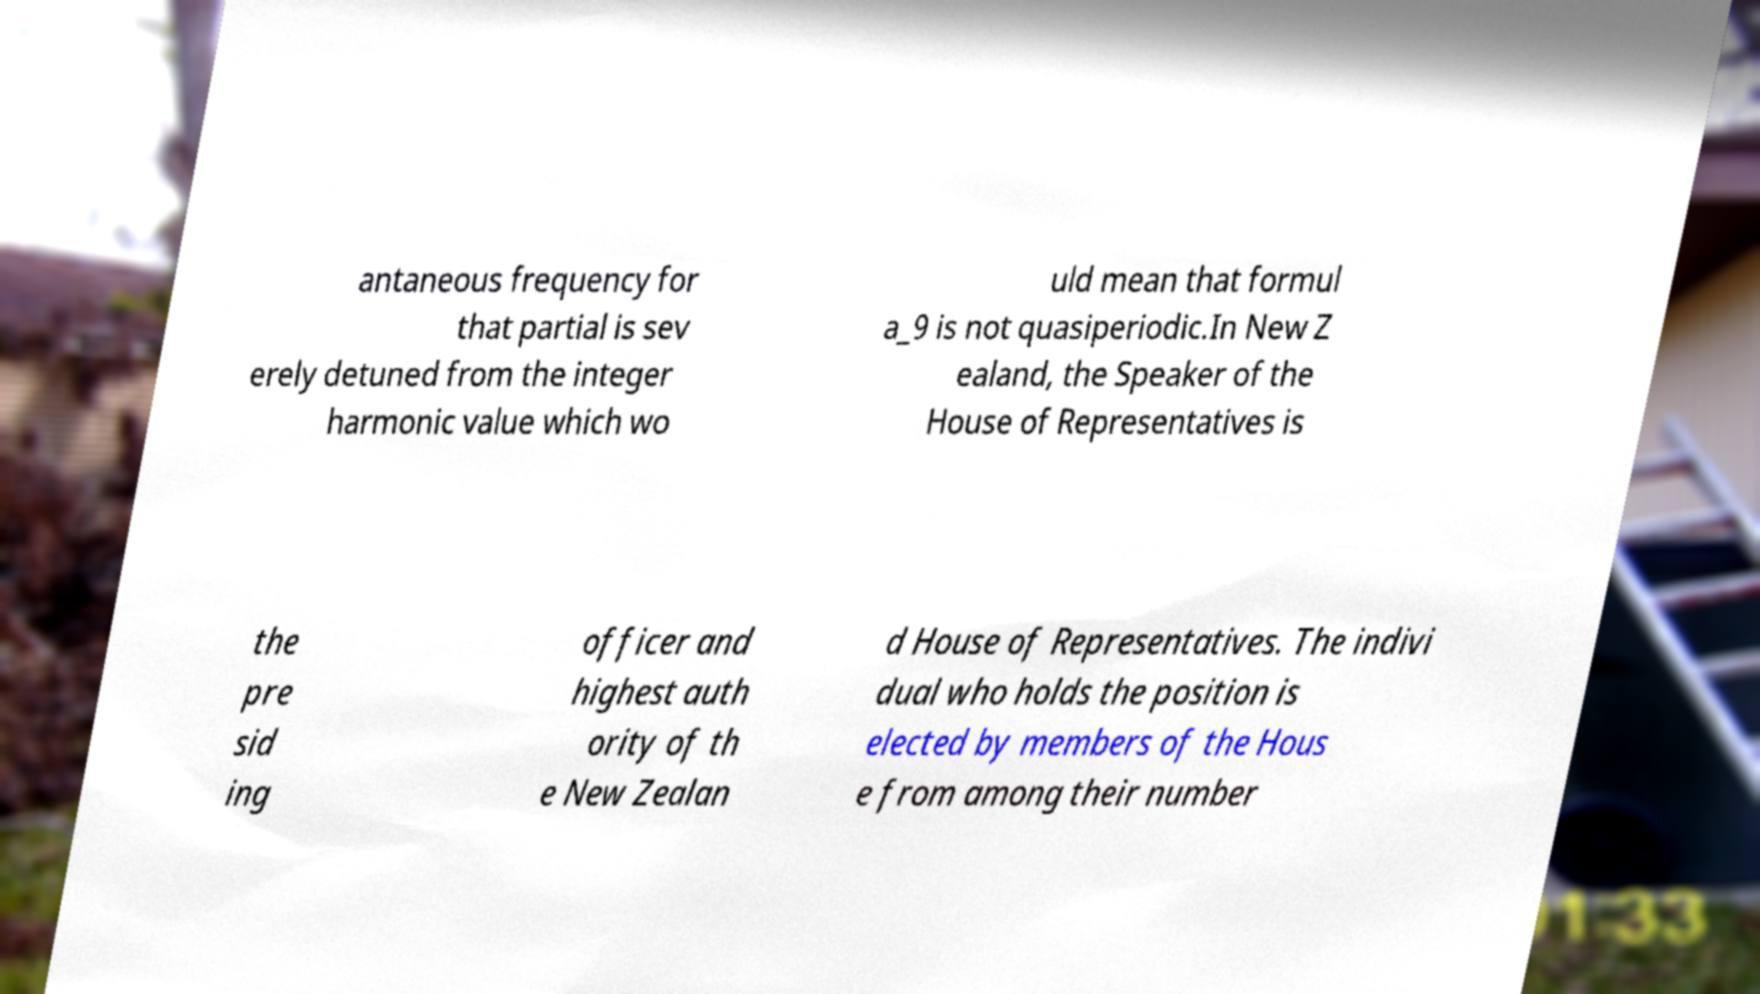Could you extract and type out the text from this image? antaneous frequency for that partial is sev erely detuned from the integer harmonic value which wo uld mean that formul a_9 is not quasiperiodic.In New Z ealand, the Speaker of the House of Representatives is the pre sid ing officer and highest auth ority of th e New Zealan d House of Representatives. The indivi dual who holds the position is elected by members of the Hous e from among their number 